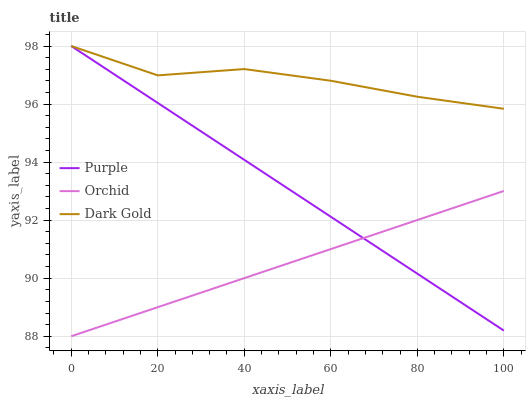Does Orchid have the minimum area under the curve?
Answer yes or no. Yes. Does Dark Gold have the maximum area under the curve?
Answer yes or no. Yes. Does Dark Gold have the minimum area under the curve?
Answer yes or no. No. Does Orchid have the maximum area under the curve?
Answer yes or no. No. Is Orchid the smoothest?
Answer yes or no. Yes. Is Dark Gold the roughest?
Answer yes or no. Yes. Is Dark Gold the smoothest?
Answer yes or no. No. Is Orchid the roughest?
Answer yes or no. No. Does Orchid have the lowest value?
Answer yes or no. Yes. Does Dark Gold have the lowest value?
Answer yes or no. No. Does Dark Gold have the highest value?
Answer yes or no. Yes. Does Orchid have the highest value?
Answer yes or no. No. Is Orchid less than Dark Gold?
Answer yes or no. Yes. Is Dark Gold greater than Orchid?
Answer yes or no. Yes. Does Purple intersect Dark Gold?
Answer yes or no. Yes. Is Purple less than Dark Gold?
Answer yes or no. No. Is Purple greater than Dark Gold?
Answer yes or no. No. Does Orchid intersect Dark Gold?
Answer yes or no. No. 